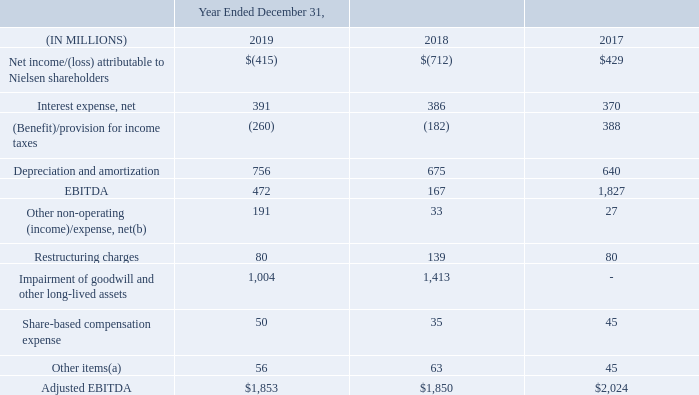Net Income to Adjusted EBITDA Reconciliation
We define Adjusted EBITDA as net income or loss from our consolidated statements of operations before interest income and expense, income taxes, depreciation and amortization, restructuring charges, impairment of goodwill and other long-lived assets, share-based compensation expense and other nonoperating items from our consolidated statements of operations as well as certain other items considered outside the normal course of our operations specifically described below.
Restructuring charges: We exclude restructuring expenses, which primarily include employee severance, office consolidation and contract termination charges, from our Adjusted EBITDA to allow more accurate comparisons of the financial results to historical operations and forward-looking guidance. By excluding these expenses from our non-GAAP measures, we are better able to evaluate our ability to utilize our existing assets and estimate the long-term value these assets will generate for us. Furthermore, we believe that the adjustments of these items more closely correlate with the sustainability of our operating performance.
Impairment of goodwill and other long-lived assets: We exclude the impact of charges related to the impairment of goodwill and other long-lived assets. Given the significance of the impairment of goodwill and other long-lived assets, we reported it separately in the consolidated statements of operations. We believe that the exclusion of these impairments, which are non-cash, allows for meaningful comparisons of operating results to peer companies. We believe that this increases period-to-period comparability and is useful to evaluate the performance of the total company.
Share-based compensation expense: We exclude the impact of costs relating to share-based compensation. Due to the subjective assumptions and a variety of award types, we believe that the exclusion of share-based compensation expense, which is typically non-cash, allows for more meaningful comparisons of our operating results to peer companies. Share-based compensation expense can vary significantly based on the timing, size and nature of awards granted.
Other non-operating income/(expense), net: We exclude foreign currency exchange transaction gains and losses, primarily related to intercompany financing arrangements, as well as other non-operating income and expense items, such as gains and losses recorded on business combinations or dispositions, sales of investments, pension settlements, net income/(loss) attributable to noncontrolling interests and early redemption payments made in connection with debt refinancing. We believe that the adjustments of these items more closely correlate with the sustainability of our operating performance.
Other items: To measure operating performance, we exclude certain expenses and gains that arise outside the ordinary course of our operations. Such costs primarily include legal settlements, acquisition related expenses, business optimization costs and other transactional costs. We believe the exclusion of such amounts allows management and the users of the financial statements to better understand our financial results.
Adjusted EBITDA is not a presentation made in accordance with GAAP, and our use of the term Adjusted EBITDA may vary from the use of similarly titled measures by others in our industry due to the potential inconsistencies in the method of calculation and differences due to items subject to interpretation. Adjusted EBITDA margin is Adjusted EBITDA for a particular period expressed as a percentage of revenues for that period.
We use Adjusted EBITDA to measure our performance from period to period both at the consolidated level as well as within our operating segments, to evaluate and fund incentive compensation programs and to compare our results to those of our competitors. In addition to Adjusted EBITDA being a significant measure of performance for management purposes, we also believe that this presentation provides useful information to investors regarding financial and business trends related to our results of operations and that when non-GAAP financial information is viewed with GAAP financial information, investors are provided with a more meaningful understanding of our ongoing operating performance.
Adjusted EBITDA should not be considered as an alternative to net income or loss, operating income/(loss), cash flows from operating activities or any other performance measures derived in accordance with GAAP as measures of operating performance or cash flows as measures of liquidity. Adjusted EBITDA has important limitations as an analytical tool and should not be considered in isolation or as a substitute for analysis of our results as reported under GAAP. In addition, our definition of Adjusted EBITDA may not be comparable to similarly titled measures of other companies and may, therefore, have limitations as a comparative analytical tool.
The below table presents a reconciliation from net income/(loss) to Adjusted EBITDA for the years ended December 31, 2019, 2018 and 2017:
(a)  For the years ended December 31, 2019 and 2018 other items primarily consists of business optimization costs, including strategic review costs and transaction related costs. For the year ended December 31, 2017, other items primarily consists of transaction related costs and business optimization costs.
(b)  For the year ended December 31, 2019, other non-operating (income)/expense, net, included non-cash expenses of $170 million for pension settlements which included plan transfers to third parties in the Netherlands and UK, where we terminated our responsibility for future defined benefit obligations and transferred that responsibility to the third parties. See Note 11 “Pensions and Other Post-Retirement Benefits” for more information.
What is the interest coverage ratio in 2019? 472/391
Answer: 1.21. What is the percentage change in the net loss from 2018 to 2019?
Answer scale should be: percent. (415-712)/712
Answer: -41.71. What is the percentage change in the adjusted EBITDA from 2018 to 2019?
Answer scale should be: percent. (1,853-1,850)/1,850
Answer: 0.16. How does share-based compensation expense vary? Based on the timing, size and nature of awards granted. When should adjusted EBITDA not be considered? In isolation or as a substitute for analysis of our results as reported under gaap. What is the EBITDA for 2019, 2018 and 2017 respectively?
Answer scale should be: million. 472, 167, 1,827. 